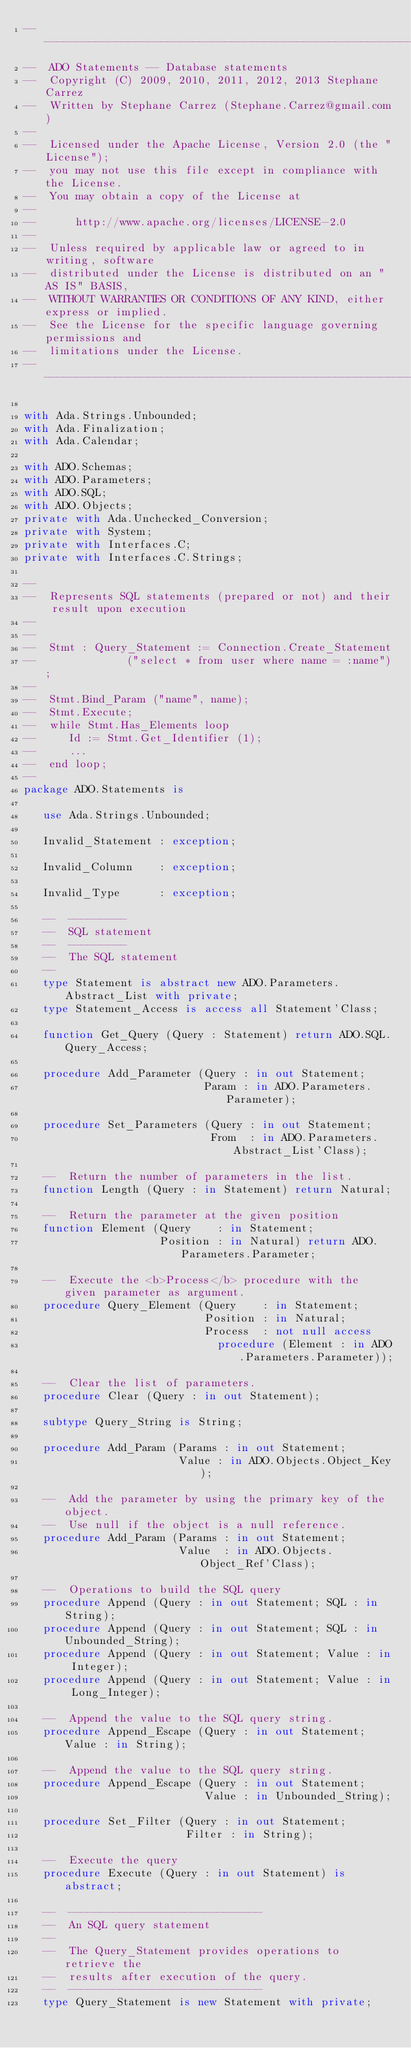Convert code to text. <code><loc_0><loc_0><loc_500><loc_500><_Ada_>-----------------------------------------------------------------------
--  ADO Statements -- Database statements
--  Copyright (C) 2009, 2010, 2011, 2012, 2013 Stephane Carrez
--  Written by Stephane Carrez (Stephane.Carrez@gmail.com)
--
--  Licensed under the Apache License, Version 2.0 (the "License");
--  you may not use this file except in compliance with the License.
--  You may obtain a copy of the License at
--
--      http://www.apache.org/licenses/LICENSE-2.0
--
--  Unless required by applicable law or agreed to in writing, software
--  distributed under the License is distributed on an "AS IS" BASIS,
--  WITHOUT WARRANTIES OR CONDITIONS OF ANY KIND, either express or implied.
--  See the License for the specific language governing permissions and
--  limitations under the License.
-----------------------------------------------------------------------

with Ada.Strings.Unbounded;
with Ada.Finalization;
with Ada.Calendar;

with ADO.Schemas;
with ADO.Parameters;
with ADO.SQL;
with ADO.Objects;
private with Ada.Unchecked_Conversion;
private with System;
private with Interfaces.C;
private with Interfaces.C.Strings;

--
--  Represents SQL statements (prepared or not) and their result upon execution
--
--
--  Stmt : Query_Statement := Connection.Create_Statement
--              ("select * from user where name = :name");
--
--  Stmt.Bind_Param ("name", name);
--  Stmt.Execute;
--  while Stmt.Has_Elements loop
--     Id := Stmt.Get_Identifier (1);
--     ...
--  end loop;
--
package ADO.Statements is

   use Ada.Strings.Unbounded;

   Invalid_Statement : exception;

   Invalid_Column    : exception;

   Invalid_Type      : exception;

   --  ---------
   --  SQL statement
   --  ---------
   --  The SQL statement
   --
   type Statement is abstract new ADO.Parameters.Abstract_List with private;
   type Statement_Access is access all Statement'Class;

   function Get_Query (Query : Statement) return ADO.SQL.Query_Access;

   procedure Add_Parameter (Query : in out Statement;
                            Param : in ADO.Parameters.Parameter);

   procedure Set_Parameters (Query : in out Statement;
                             From  : in ADO.Parameters.Abstract_List'Class);

   --  Return the number of parameters in the list.
   function Length (Query : in Statement) return Natural;

   --  Return the parameter at the given position
   function Element (Query    : in Statement;
                     Position : in Natural) return ADO.Parameters.Parameter;

   --  Execute the <b>Process</b> procedure with the given parameter as argument.
   procedure Query_Element (Query    : in Statement;
                            Position : in Natural;
                            Process  : not null access
                              procedure (Element : in ADO.Parameters.Parameter));

   --  Clear the list of parameters.
   procedure Clear (Query : in out Statement);

   subtype Query_String is String;

   procedure Add_Param (Params : in out Statement;
                        Value : in ADO.Objects.Object_Key);

   --  Add the parameter by using the primary key of the object.
   --  Use null if the object is a null reference.
   procedure Add_Param (Params : in out Statement;
                        Value  : in ADO.Objects.Object_Ref'Class);

   --  Operations to build the SQL query
   procedure Append (Query : in out Statement; SQL : in String);
   procedure Append (Query : in out Statement; SQL : in Unbounded_String);
   procedure Append (Query : in out Statement; Value : in Integer);
   procedure Append (Query : in out Statement; Value : in Long_Integer);

   --  Append the value to the SQL query string.
   procedure Append_Escape (Query : in out Statement; Value : in String);

   --  Append the value to the SQL query string.
   procedure Append_Escape (Query : in out Statement;
                            Value : in Unbounded_String);

   procedure Set_Filter (Query : in out Statement;
                         Filter : in String);

   --  Execute the query
   procedure Execute (Query : in out Statement) is abstract;

   --  ------------------------------
   --  An SQL query statement
   --
   --  The Query_Statement provides operations to retrieve the
   --  results after execution of the query.
   --  ------------------------------
   type Query_Statement is new Statement with private;</code> 